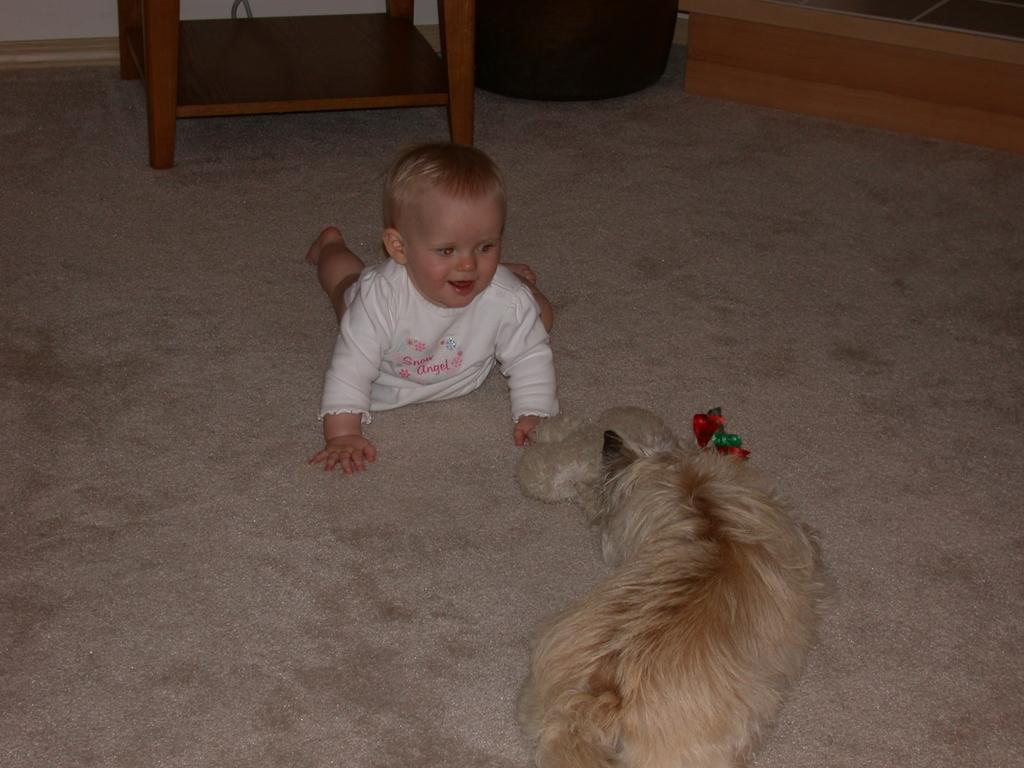What is the kid doing in the image? The kid is crawling on the floor. What is the kid wearing? The kid is wearing a white dress. What can be seen in front of the kid? There is a dog in front of the kid. What type of furniture is present in the image? There is a wooden table in the image. What type of bait is the dog using to catch fish in the image? There is no indication of fishing or bait in the image; it features a kid crawling on the floor with a dog in front of them and a wooden table. 